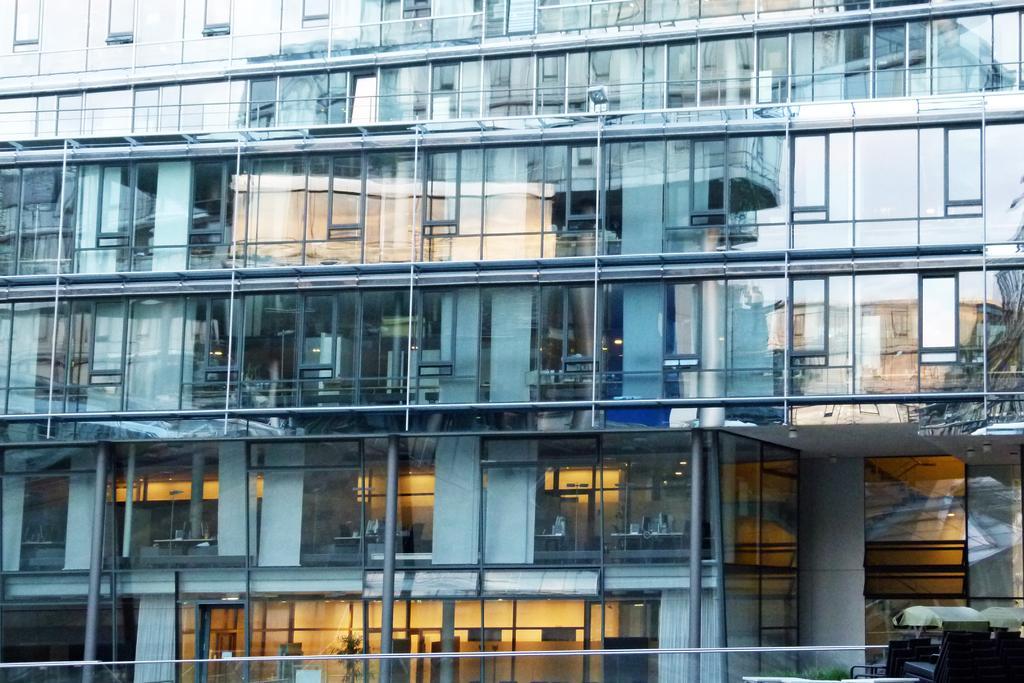Could you give a brief overview of what you see in this image? In this picture I can see the building. In the bottom right corner I can see the plants and benches. Inside the building I can see the laptop's, mouse, chairs and other objects on the table. 